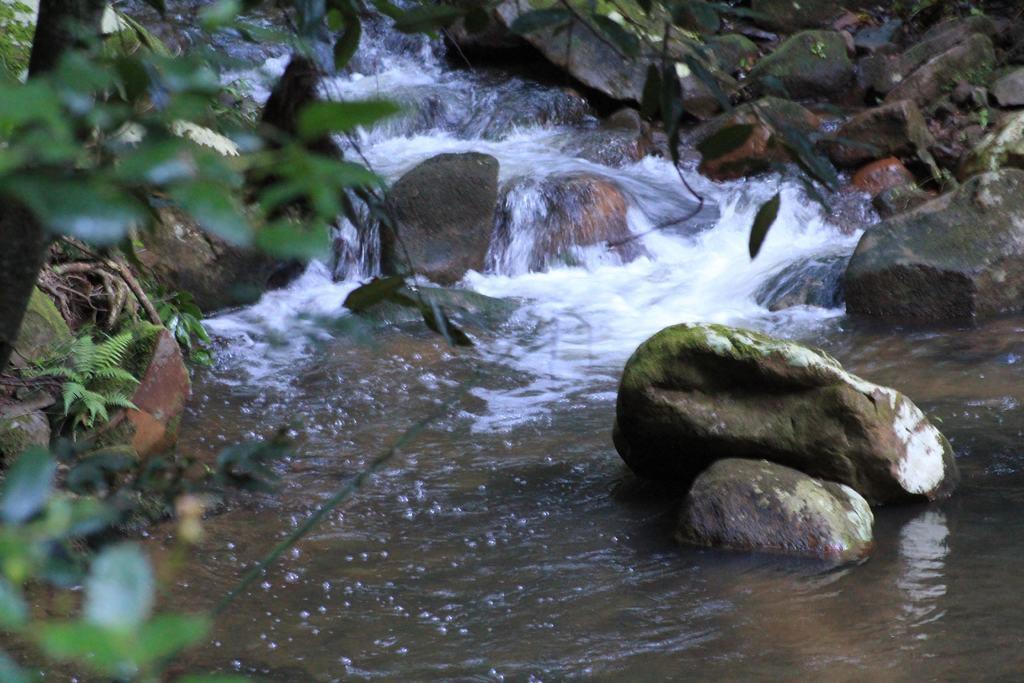Could you give a brief overview of what you see in this image? In this image we can see the trees, stones and water flow. 